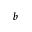<formula> <loc_0><loc_0><loc_500><loc_500>_ { b }</formula> 